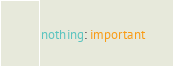Convert code to text. <code><loc_0><loc_0><loc_500><loc_500><_YAML_>nothing: important
</code> 